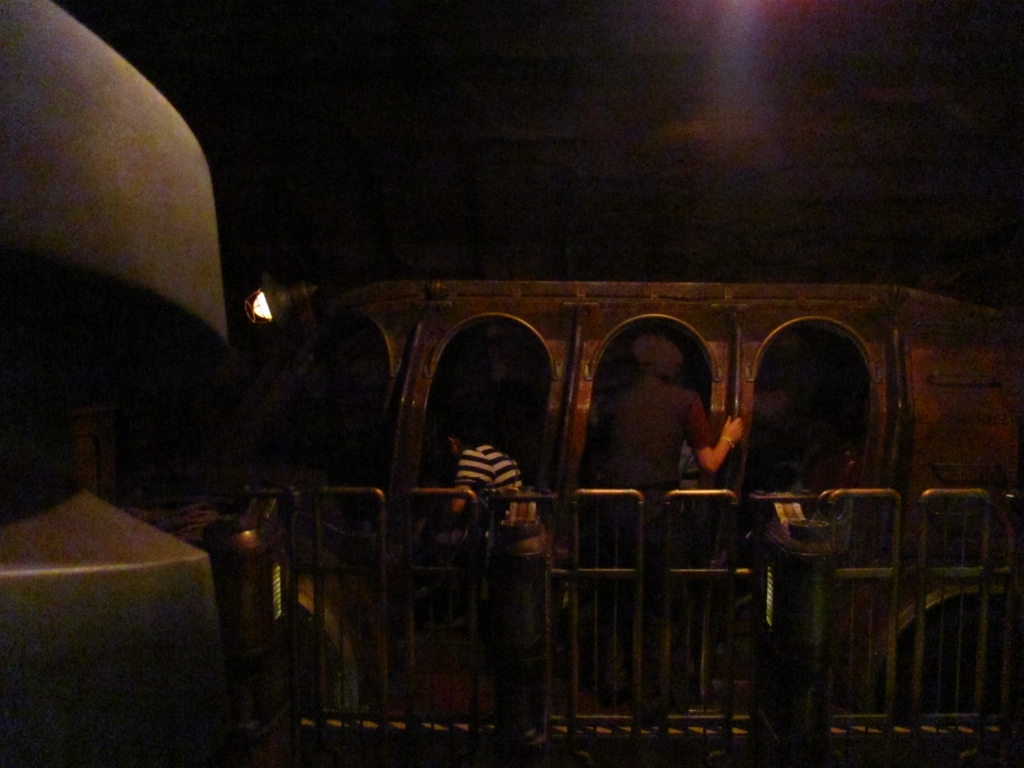Can you describe the setting of this image? The image shows an indoor setting, possibly a ride or attraction at an amusement park or themed event. There are rounded compartments that resemble a train's carriages, and it has a vintage or rustic design. The ambient lighting suggests an attempt to create an immersive, mysterious atmosphere. 